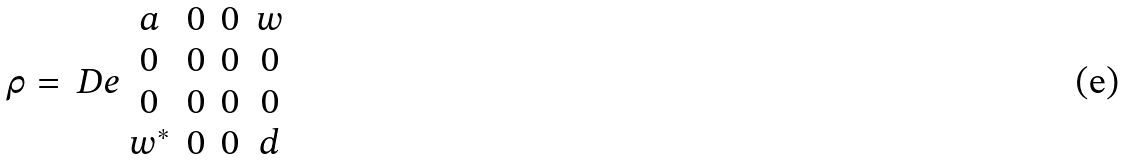<formula> <loc_0><loc_0><loc_500><loc_500>\rho = \ D e { \begin{array} { c c c c } a & 0 & 0 & w \\ 0 & 0 & 0 & 0 \\ 0 & 0 & 0 & 0 \\ w ^ { * } & 0 & 0 & d \end{array} }</formula> 